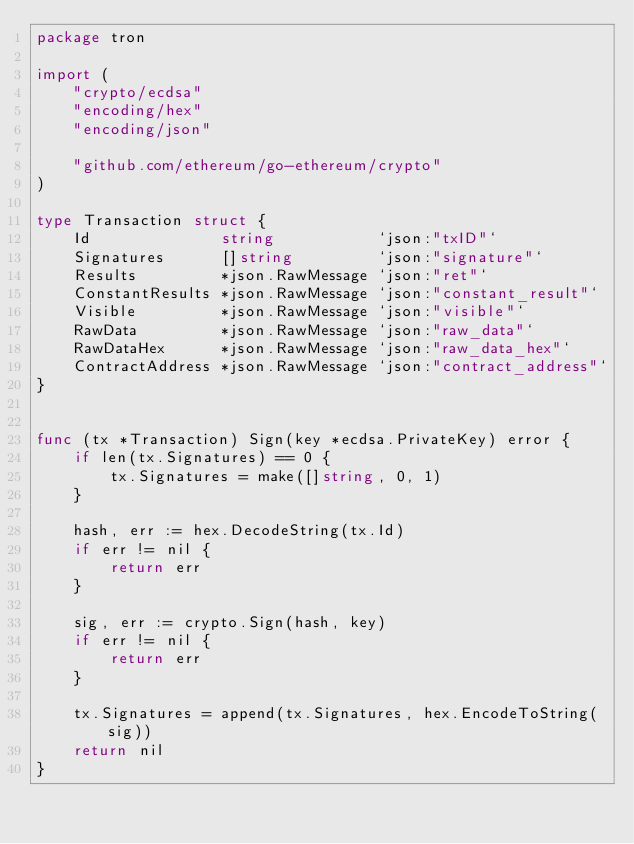<code> <loc_0><loc_0><loc_500><loc_500><_Go_>package tron

import (
	"crypto/ecdsa"
	"encoding/hex"
	"encoding/json"

	"github.com/ethereum/go-ethereum/crypto"
)

type Transaction struct {
	Id              string           `json:"txID"`
	Signatures      []string         `json:"signature"`
	Results         *json.RawMessage `json:"ret"`
	ConstantResults *json.RawMessage `json:"constant_result"`
	Visible         *json.RawMessage `json:"visible"`
	RawData         *json.RawMessage `json:"raw_data"`
	RawDataHex      *json.RawMessage `json:"raw_data_hex"`
	ContractAddress *json.RawMessage `json:"contract_address"`
}


func (tx *Transaction) Sign(key *ecdsa.PrivateKey) error {
	if len(tx.Signatures) == 0 {
		tx.Signatures = make([]string, 0, 1)
	}

	hash, err := hex.DecodeString(tx.Id)
	if err != nil {
		return err
	}

	sig, err := crypto.Sign(hash, key)
	if err != nil {
		return err
	}

	tx.Signatures = append(tx.Signatures, hex.EncodeToString(sig))
	return nil
}
</code> 